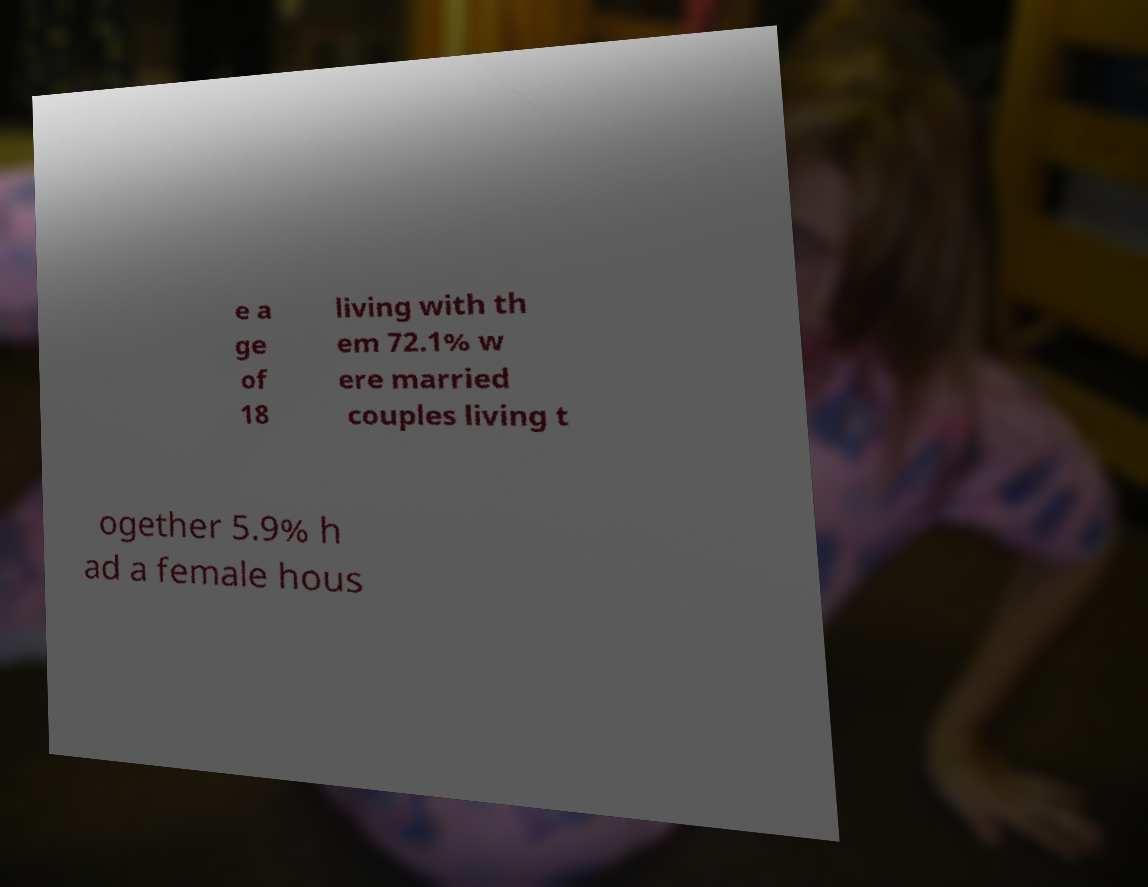What messages or text are displayed in this image? I need them in a readable, typed format. e a ge of 18 living with th em 72.1% w ere married couples living t ogether 5.9% h ad a female hous 